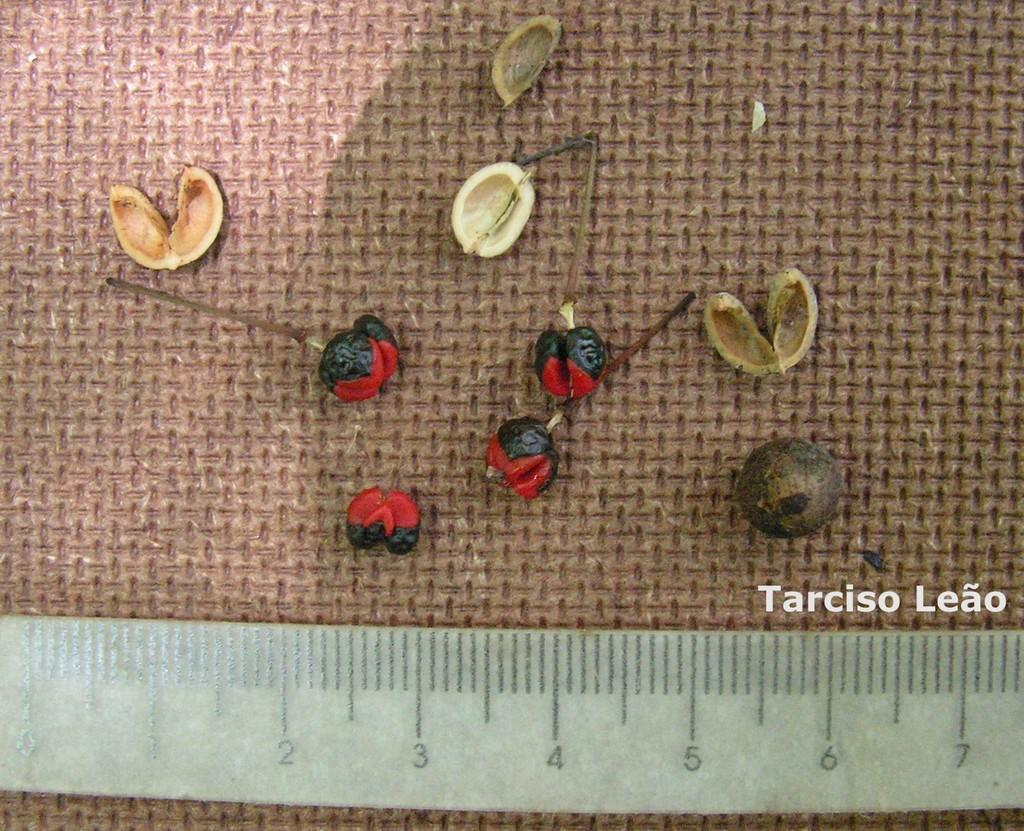<image>
Write a terse but informative summary of the picture. Some type of nuts or seeds is arranged next to a ruler and the image is labelled Tarciso Leao. 